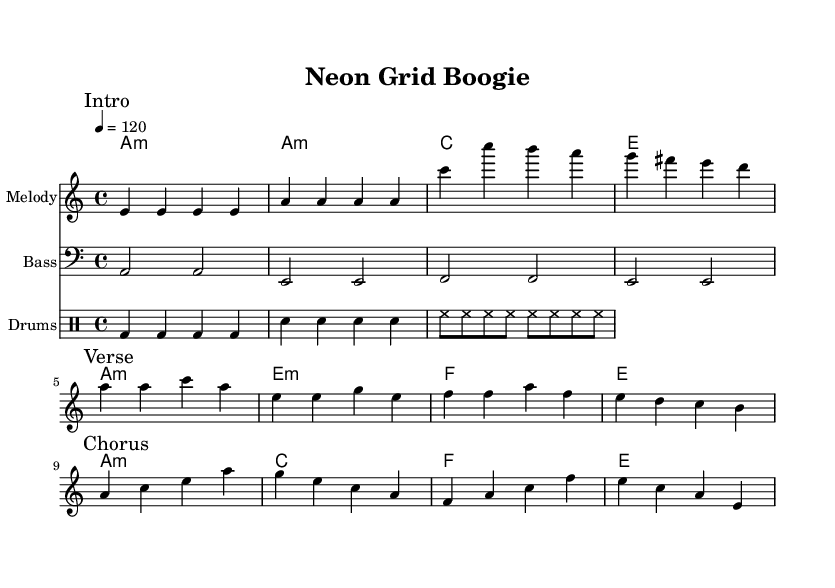What is the key signature of this music? The key signature is A minor, which has no sharps or flats. This is determined by the key specified in the global variable of the code.
Answer: A minor What is the time signature of this music? The time signature is 4/4, as noted in the global variable section of the code. This indicates that there are four beats in each measure and the quarter note receives one beat.
Answer: 4/4 What is the tempo marking for this piece? The tempo marking indicates a speed of 120 beats per minute. This is found in the global section under tempo, specifically noted as "4 = 120."
Answer: 120 What are the first four notes of the melody? The first four notes of the melody are E E E E. This can be located at the beginning of the melody section where the notes are listed.
Answer: E E E E How many measures are there in the verse section? The verse section contains four measures, as can be seen in the corresponding section under "Verse" in the melody part. Counting the bars under that segment provides the total.
Answer: 4 What chord follows the A minor chord in the harmony? The chord following the A minor in the harmony section is E minor. By examining the harmonies code section, the sequence shows A minor followed by E minor.
Answer: E minor What drum pattern is indicated for the bass drum? The drum pattern for the bass drum consists of four quarter notes in succession. This is evident in the drum section under "bd4 bd bd bd," indicating four beats of bass drum hits.
Answer: Four quarter notes 